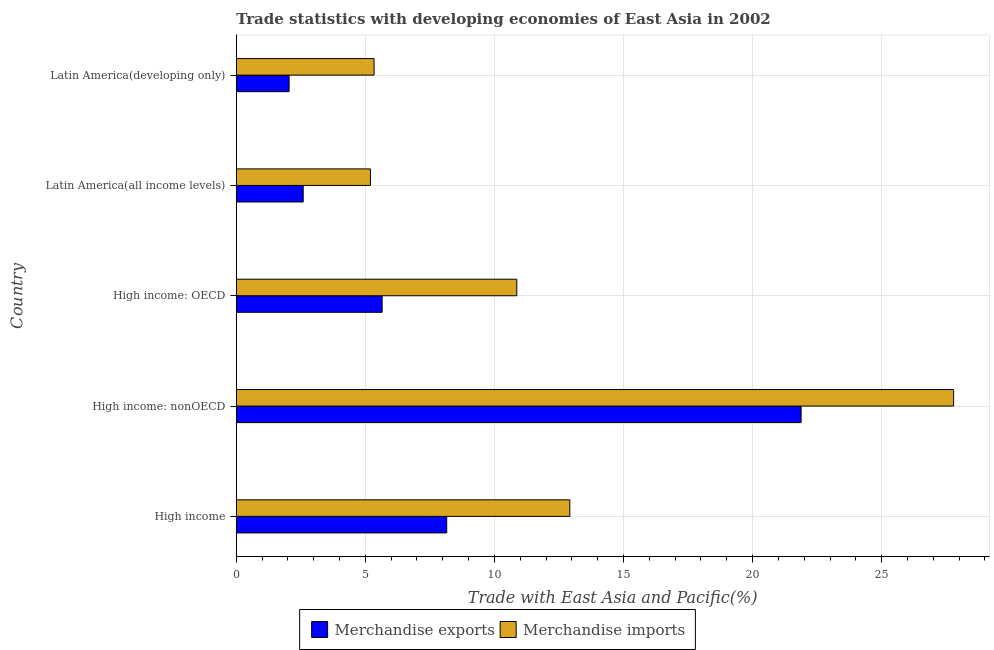How many different coloured bars are there?
Provide a succinct answer. 2. Are the number of bars per tick equal to the number of legend labels?
Keep it short and to the point. Yes. How many bars are there on the 5th tick from the bottom?
Your answer should be very brief. 2. What is the label of the 4th group of bars from the top?
Ensure brevity in your answer.  High income: nonOECD. In how many cases, is the number of bars for a given country not equal to the number of legend labels?
Your answer should be very brief. 0. What is the merchandise imports in Latin America(developing only)?
Offer a very short reply. 5.34. Across all countries, what is the maximum merchandise exports?
Provide a short and direct response. 21.88. Across all countries, what is the minimum merchandise exports?
Provide a short and direct response. 2.05. In which country was the merchandise exports maximum?
Provide a short and direct response. High income: nonOECD. In which country was the merchandise exports minimum?
Ensure brevity in your answer.  Latin America(developing only). What is the total merchandise imports in the graph?
Keep it short and to the point. 62.11. What is the difference between the merchandise imports in High income and that in Latin America(developing only)?
Provide a succinct answer. 7.58. What is the difference between the merchandise exports in High income: OECD and the merchandise imports in Latin America(all income levels)?
Your answer should be compact. 0.45. What is the average merchandise imports per country?
Offer a terse response. 12.42. What is the difference between the merchandise imports and merchandise exports in Latin America(developing only)?
Your answer should be compact. 3.29. What is the ratio of the merchandise imports in High income: OECD to that in Latin America(developing only)?
Your answer should be very brief. 2.04. Is the merchandise exports in High income: OECD less than that in Latin America(developing only)?
Offer a very short reply. No. Is the difference between the merchandise imports in High income and Latin America(developing only) greater than the difference between the merchandise exports in High income and Latin America(developing only)?
Offer a very short reply. Yes. What is the difference between the highest and the second highest merchandise imports?
Ensure brevity in your answer.  14.87. What is the difference between the highest and the lowest merchandise exports?
Provide a succinct answer. 19.83. Is the sum of the merchandise imports in High income and High income: OECD greater than the maximum merchandise exports across all countries?
Your answer should be very brief. Yes. What does the 1st bar from the top in High income: nonOECD represents?
Provide a short and direct response. Merchandise imports. What does the 1st bar from the bottom in High income represents?
Your answer should be compact. Merchandise exports. How many bars are there?
Offer a terse response. 10. Are the values on the major ticks of X-axis written in scientific E-notation?
Offer a very short reply. No. How many legend labels are there?
Make the answer very short. 2. What is the title of the graph?
Offer a very short reply. Trade statistics with developing economies of East Asia in 2002. What is the label or title of the X-axis?
Provide a short and direct response. Trade with East Asia and Pacific(%). What is the label or title of the Y-axis?
Offer a very short reply. Country. What is the Trade with East Asia and Pacific(%) of Merchandise exports in High income?
Provide a short and direct response. 8.15. What is the Trade with East Asia and Pacific(%) of Merchandise imports in High income?
Your response must be concise. 12.92. What is the Trade with East Asia and Pacific(%) in Merchandise exports in High income: nonOECD?
Offer a very short reply. 21.88. What is the Trade with East Asia and Pacific(%) of Merchandise imports in High income: nonOECD?
Give a very brief answer. 27.79. What is the Trade with East Asia and Pacific(%) of Merchandise exports in High income: OECD?
Make the answer very short. 5.65. What is the Trade with East Asia and Pacific(%) of Merchandise imports in High income: OECD?
Ensure brevity in your answer.  10.87. What is the Trade with East Asia and Pacific(%) in Merchandise exports in Latin America(all income levels)?
Offer a terse response. 2.59. What is the Trade with East Asia and Pacific(%) of Merchandise imports in Latin America(all income levels)?
Provide a succinct answer. 5.2. What is the Trade with East Asia and Pacific(%) in Merchandise exports in Latin America(developing only)?
Keep it short and to the point. 2.05. What is the Trade with East Asia and Pacific(%) in Merchandise imports in Latin America(developing only)?
Make the answer very short. 5.34. Across all countries, what is the maximum Trade with East Asia and Pacific(%) in Merchandise exports?
Offer a terse response. 21.88. Across all countries, what is the maximum Trade with East Asia and Pacific(%) in Merchandise imports?
Make the answer very short. 27.79. Across all countries, what is the minimum Trade with East Asia and Pacific(%) in Merchandise exports?
Your response must be concise. 2.05. Across all countries, what is the minimum Trade with East Asia and Pacific(%) in Merchandise imports?
Offer a very short reply. 5.2. What is the total Trade with East Asia and Pacific(%) of Merchandise exports in the graph?
Provide a short and direct response. 40.32. What is the total Trade with East Asia and Pacific(%) of Merchandise imports in the graph?
Ensure brevity in your answer.  62.11. What is the difference between the Trade with East Asia and Pacific(%) in Merchandise exports in High income and that in High income: nonOECD?
Your response must be concise. -13.73. What is the difference between the Trade with East Asia and Pacific(%) of Merchandise imports in High income and that in High income: nonOECD?
Ensure brevity in your answer.  -14.87. What is the difference between the Trade with East Asia and Pacific(%) in Merchandise exports in High income and that in High income: OECD?
Offer a very short reply. 2.5. What is the difference between the Trade with East Asia and Pacific(%) in Merchandise imports in High income and that in High income: OECD?
Your answer should be compact. 2.05. What is the difference between the Trade with East Asia and Pacific(%) of Merchandise exports in High income and that in Latin America(all income levels)?
Your answer should be compact. 5.56. What is the difference between the Trade with East Asia and Pacific(%) of Merchandise imports in High income and that in Latin America(all income levels)?
Your answer should be compact. 7.72. What is the difference between the Trade with East Asia and Pacific(%) in Merchandise exports in High income and that in Latin America(developing only)?
Keep it short and to the point. 6.11. What is the difference between the Trade with East Asia and Pacific(%) in Merchandise imports in High income and that in Latin America(developing only)?
Your response must be concise. 7.58. What is the difference between the Trade with East Asia and Pacific(%) of Merchandise exports in High income: nonOECD and that in High income: OECD?
Offer a very short reply. 16.23. What is the difference between the Trade with East Asia and Pacific(%) of Merchandise imports in High income: nonOECD and that in High income: OECD?
Keep it short and to the point. 16.92. What is the difference between the Trade with East Asia and Pacific(%) in Merchandise exports in High income: nonOECD and that in Latin America(all income levels)?
Provide a succinct answer. 19.29. What is the difference between the Trade with East Asia and Pacific(%) of Merchandise imports in High income: nonOECD and that in Latin America(all income levels)?
Give a very brief answer. 22.59. What is the difference between the Trade with East Asia and Pacific(%) in Merchandise exports in High income: nonOECD and that in Latin America(developing only)?
Ensure brevity in your answer.  19.83. What is the difference between the Trade with East Asia and Pacific(%) of Merchandise imports in High income: nonOECD and that in Latin America(developing only)?
Provide a short and direct response. 22.45. What is the difference between the Trade with East Asia and Pacific(%) of Merchandise exports in High income: OECD and that in Latin America(all income levels)?
Offer a very short reply. 3.06. What is the difference between the Trade with East Asia and Pacific(%) in Merchandise imports in High income: OECD and that in Latin America(all income levels)?
Keep it short and to the point. 5.67. What is the difference between the Trade with East Asia and Pacific(%) in Merchandise exports in High income: OECD and that in Latin America(developing only)?
Your response must be concise. 3.6. What is the difference between the Trade with East Asia and Pacific(%) of Merchandise imports in High income: OECD and that in Latin America(developing only)?
Ensure brevity in your answer.  5.53. What is the difference between the Trade with East Asia and Pacific(%) of Merchandise exports in Latin America(all income levels) and that in Latin America(developing only)?
Provide a short and direct response. 0.55. What is the difference between the Trade with East Asia and Pacific(%) in Merchandise imports in Latin America(all income levels) and that in Latin America(developing only)?
Your answer should be very brief. -0.14. What is the difference between the Trade with East Asia and Pacific(%) in Merchandise exports in High income and the Trade with East Asia and Pacific(%) in Merchandise imports in High income: nonOECD?
Your answer should be compact. -19.63. What is the difference between the Trade with East Asia and Pacific(%) in Merchandise exports in High income and the Trade with East Asia and Pacific(%) in Merchandise imports in High income: OECD?
Give a very brief answer. -2.71. What is the difference between the Trade with East Asia and Pacific(%) of Merchandise exports in High income and the Trade with East Asia and Pacific(%) of Merchandise imports in Latin America(all income levels)?
Make the answer very short. 2.95. What is the difference between the Trade with East Asia and Pacific(%) in Merchandise exports in High income and the Trade with East Asia and Pacific(%) in Merchandise imports in Latin America(developing only)?
Give a very brief answer. 2.81. What is the difference between the Trade with East Asia and Pacific(%) in Merchandise exports in High income: nonOECD and the Trade with East Asia and Pacific(%) in Merchandise imports in High income: OECD?
Provide a short and direct response. 11.01. What is the difference between the Trade with East Asia and Pacific(%) in Merchandise exports in High income: nonOECD and the Trade with East Asia and Pacific(%) in Merchandise imports in Latin America(all income levels)?
Make the answer very short. 16.68. What is the difference between the Trade with East Asia and Pacific(%) of Merchandise exports in High income: nonOECD and the Trade with East Asia and Pacific(%) of Merchandise imports in Latin America(developing only)?
Provide a succinct answer. 16.54. What is the difference between the Trade with East Asia and Pacific(%) in Merchandise exports in High income: OECD and the Trade with East Asia and Pacific(%) in Merchandise imports in Latin America(all income levels)?
Ensure brevity in your answer.  0.45. What is the difference between the Trade with East Asia and Pacific(%) of Merchandise exports in High income: OECD and the Trade with East Asia and Pacific(%) of Merchandise imports in Latin America(developing only)?
Offer a terse response. 0.31. What is the difference between the Trade with East Asia and Pacific(%) in Merchandise exports in Latin America(all income levels) and the Trade with East Asia and Pacific(%) in Merchandise imports in Latin America(developing only)?
Offer a terse response. -2.75. What is the average Trade with East Asia and Pacific(%) of Merchandise exports per country?
Keep it short and to the point. 8.06. What is the average Trade with East Asia and Pacific(%) of Merchandise imports per country?
Give a very brief answer. 12.42. What is the difference between the Trade with East Asia and Pacific(%) of Merchandise exports and Trade with East Asia and Pacific(%) of Merchandise imports in High income?
Give a very brief answer. -4.77. What is the difference between the Trade with East Asia and Pacific(%) in Merchandise exports and Trade with East Asia and Pacific(%) in Merchandise imports in High income: nonOECD?
Make the answer very short. -5.91. What is the difference between the Trade with East Asia and Pacific(%) in Merchandise exports and Trade with East Asia and Pacific(%) in Merchandise imports in High income: OECD?
Keep it short and to the point. -5.21. What is the difference between the Trade with East Asia and Pacific(%) of Merchandise exports and Trade with East Asia and Pacific(%) of Merchandise imports in Latin America(all income levels)?
Ensure brevity in your answer.  -2.61. What is the difference between the Trade with East Asia and Pacific(%) of Merchandise exports and Trade with East Asia and Pacific(%) of Merchandise imports in Latin America(developing only)?
Your answer should be very brief. -3.29. What is the ratio of the Trade with East Asia and Pacific(%) of Merchandise exports in High income to that in High income: nonOECD?
Offer a very short reply. 0.37. What is the ratio of the Trade with East Asia and Pacific(%) of Merchandise imports in High income to that in High income: nonOECD?
Offer a terse response. 0.46. What is the ratio of the Trade with East Asia and Pacific(%) of Merchandise exports in High income to that in High income: OECD?
Your response must be concise. 1.44. What is the ratio of the Trade with East Asia and Pacific(%) of Merchandise imports in High income to that in High income: OECD?
Your answer should be compact. 1.19. What is the ratio of the Trade with East Asia and Pacific(%) of Merchandise exports in High income to that in Latin America(all income levels)?
Offer a very short reply. 3.14. What is the ratio of the Trade with East Asia and Pacific(%) in Merchandise imports in High income to that in Latin America(all income levels)?
Make the answer very short. 2.49. What is the ratio of the Trade with East Asia and Pacific(%) in Merchandise exports in High income to that in Latin America(developing only)?
Your response must be concise. 3.98. What is the ratio of the Trade with East Asia and Pacific(%) in Merchandise imports in High income to that in Latin America(developing only)?
Your answer should be compact. 2.42. What is the ratio of the Trade with East Asia and Pacific(%) of Merchandise exports in High income: nonOECD to that in High income: OECD?
Make the answer very short. 3.87. What is the ratio of the Trade with East Asia and Pacific(%) of Merchandise imports in High income: nonOECD to that in High income: OECD?
Offer a terse response. 2.56. What is the ratio of the Trade with East Asia and Pacific(%) in Merchandise exports in High income: nonOECD to that in Latin America(all income levels)?
Give a very brief answer. 8.44. What is the ratio of the Trade with East Asia and Pacific(%) of Merchandise imports in High income: nonOECD to that in Latin America(all income levels)?
Provide a succinct answer. 5.35. What is the ratio of the Trade with East Asia and Pacific(%) in Merchandise exports in High income: nonOECD to that in Latin America(developing only)?
Ensure brevity in your answer.  10.69. What is the ratio of the Trade with East Asia and Pacific(%) of Merchandise imports in High income: nonOECD to that in Latin America(developing only)?
Your response must be concise. 5.2. What is the ratio of the Trade with East Asia and Pacific(%) of Merchandise exports in High income: OECD to that in Latin America(all income levels)?
Your answer should be compact. 2.18. What is the ratio of the Trade with East Asia and Pacific(%) of Merchandise imports in High income: OECD to that in Latin America(all income levels)?
Your answer should be compact. 2.09. What is the ratio of the Trade with East Asia and Pacific(%) of Merchandise exports in High income: OECD to that in Latin America(developing only)?
Your answer should be compact. 2.76. What is the ratio of the Trade with East Asia and Pacific(%) of Merchandise imports in High income: OECD to that in Latin America(developing only)?
Provide a short and direct response. 2.04. What is the ratio of the Trade with East Asia and Pacific(%) in Merchandise exports in Latin America(all income levels) to that in Latin America(developing only)?
Your response must be concise. 1.27. What is the ratio of the Trade with East Asia and Pacific(%) of Merchandise imports in Latin America(all income levels) to that in Latin America(developing only)?
Your response must be concise. 0.97. What is the difference between the highest and the second highest Trade with East Asia and Pacific(%) in Merchandise exports?
Provide a succinct answer. 13.73. What is the difference between the highest and the second highest Trade with East Asia and Pacific(%) in Merchandise imports?
Provide a short and direct response. 14.87. What is the difference between the highest and the lowest Trade with East Asia and Pacific(%) of Merchandise exports?
Give a very brief answer. 19.83. What is the difference between the highest and the lowest Trade with East Asia and Pacific(%) in Merchandise imports?
Offer a very short reply. 22.59. 